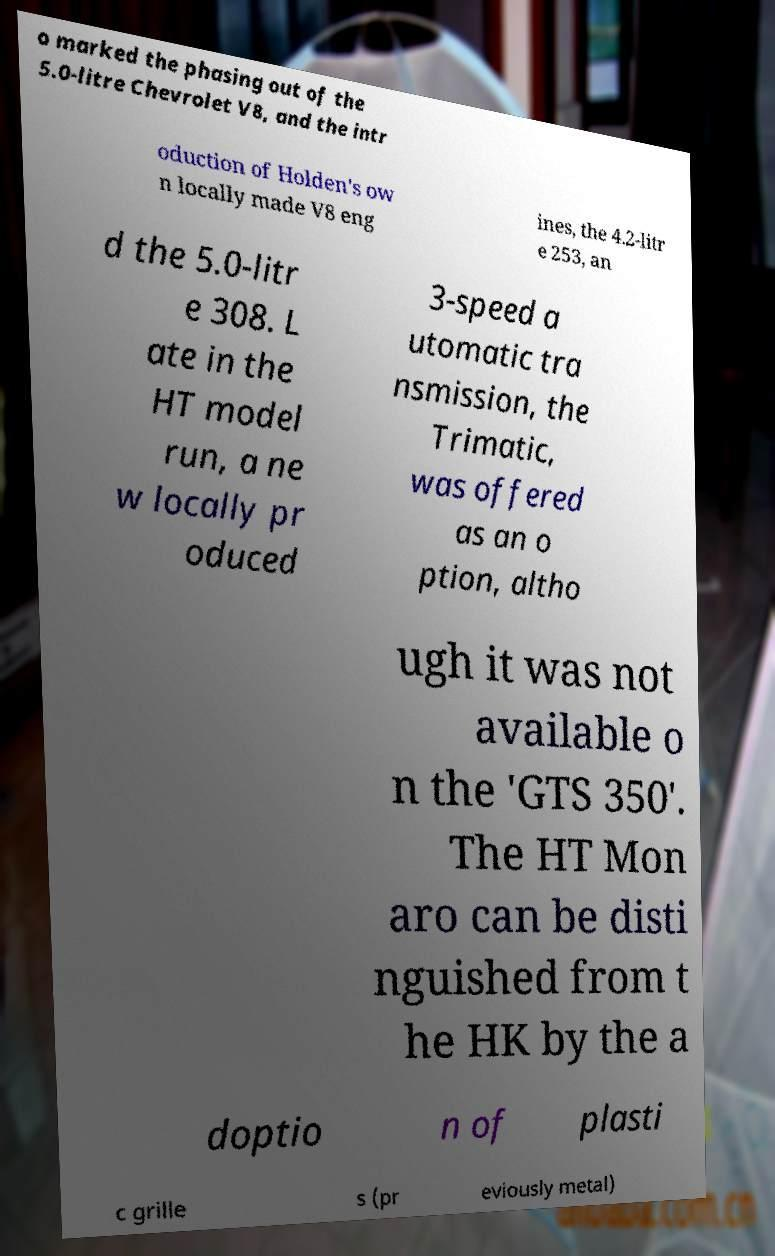Could you assist in decoding the text presented in this image and type it out clearly? o marked the phasing out of the 5.0-litre Chevrolet V8, and the intr oduction of Holden's ow n locally made V8 eng ines, the 4.2-litr e 253, an d the 5.0-litr e 308. L ate in the HT model run, a ne w locally pr oduced 3-speed a utomatic tra nsmission, the Trimatic, was offered as an o ption, altho ugh it was not available o n the 'GTS 350'. The HT Mon aro can be disti nguished from t he HK by the a doptio n of plasti c grille s (pr eviously metal) 